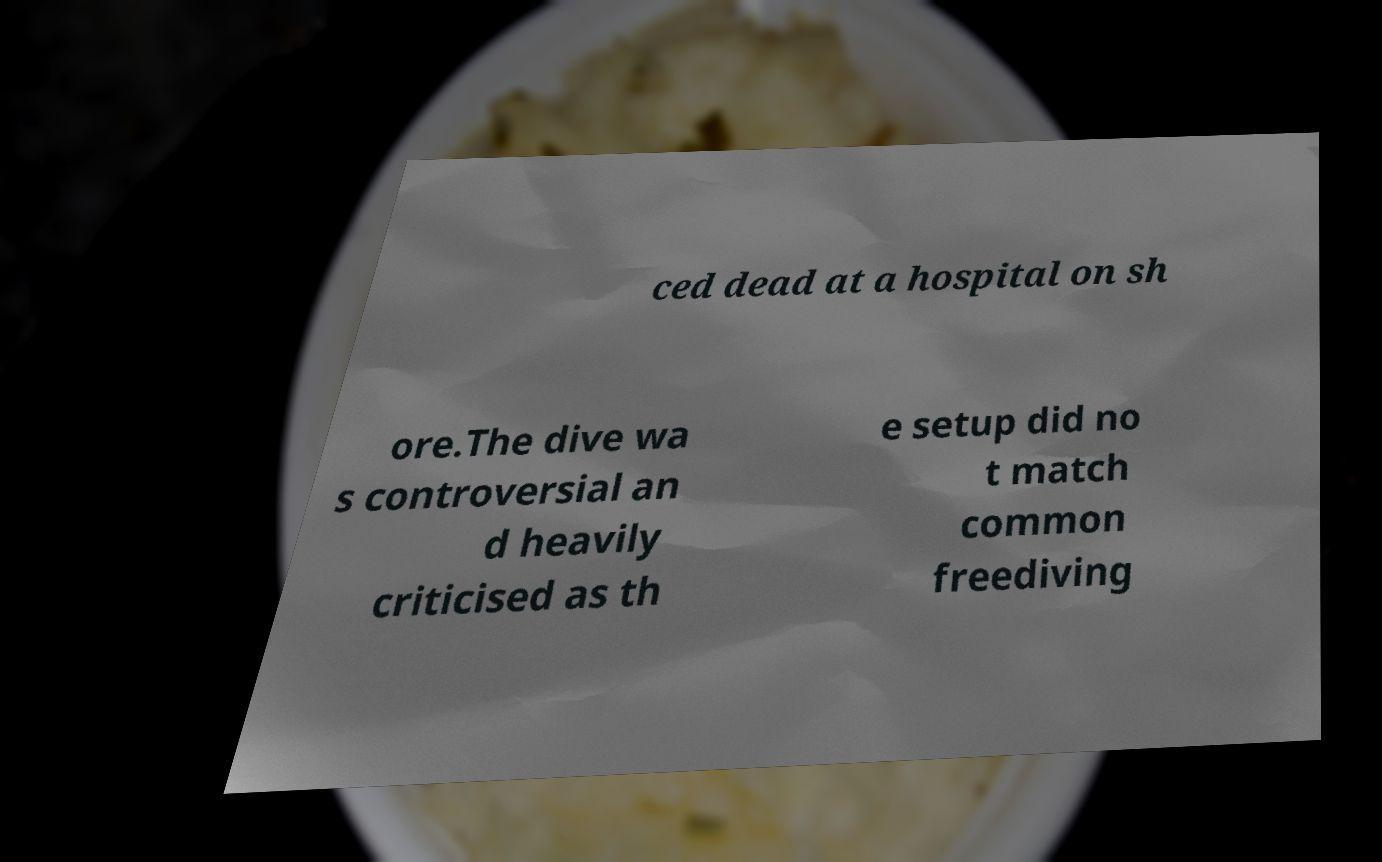There's text embedded in this image that I need extracted. Can you transcribe it verbatim? ced dead at a hospital on sh ore.The dive wa s controversial an d heavily criticised as th e setup did no t match common freediving 